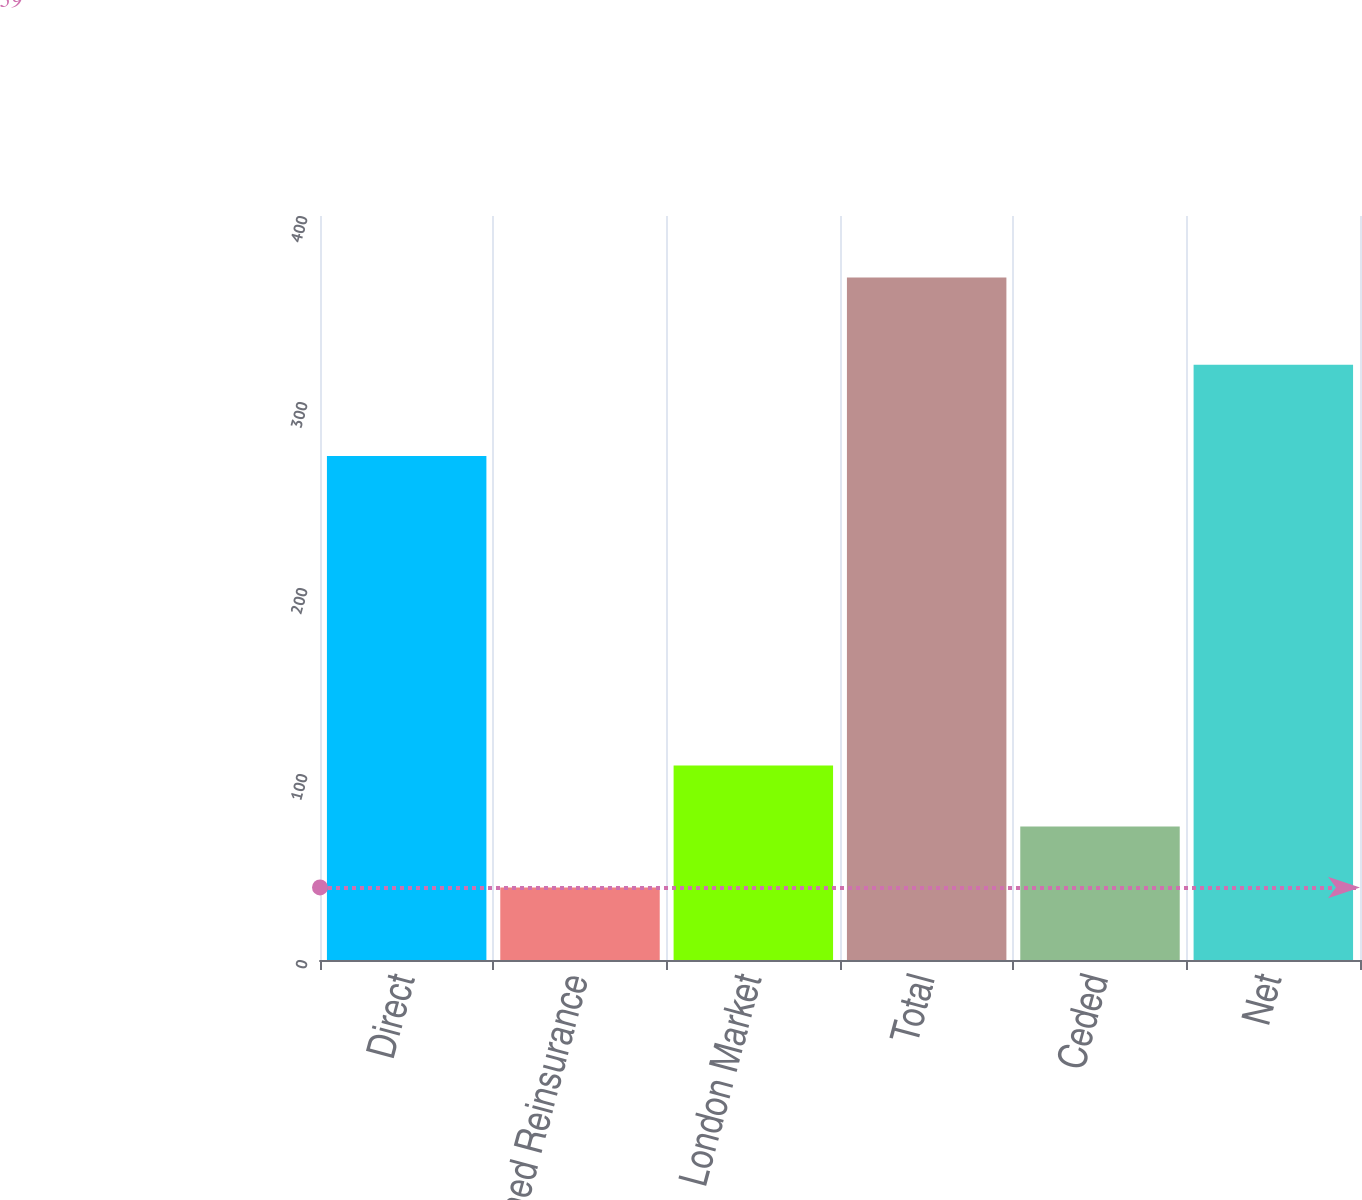<chart> <loc_0><loc_0><loc_500><loc_500><bar_chart><fcel>Direct<fcel>Assumed Reinsurance<fcel>London Market<fcel>Total<fcel>Ceded<fcel>Net<nl><fcel>271<fcel>39<fcel>104.6<fcel>367<fcel>71.8<fcel>320<nl></chart> 